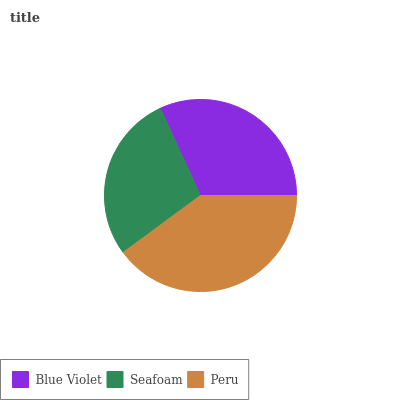Is Seafoam the minimum?
Answer yes or no. Yes. Is Peru the maximum?
Answer yes or no. Yes. Is Peru the minimum?
Answer yes or no. No. Is Seafoam the maximum?
Answer yes or no. No. Is Peru greater than Seafoam?
Answer yes or no. Yes. Is Seafoam less than Peru?
Answer yes or no. Yes. Is Seafoam greater than Peru?
Answer yes or no. No. Is Peru less than Seafoam?
Answer yes or no. No. Is Blue Violet the high median?
Answer yes or no. Yes. Is Blue Violet the low median?
Answer yes or no. Yes. Is Peru the high median?
Answer yes or no. No. Is Seafoam the low median?
Answer yes or no. No. 